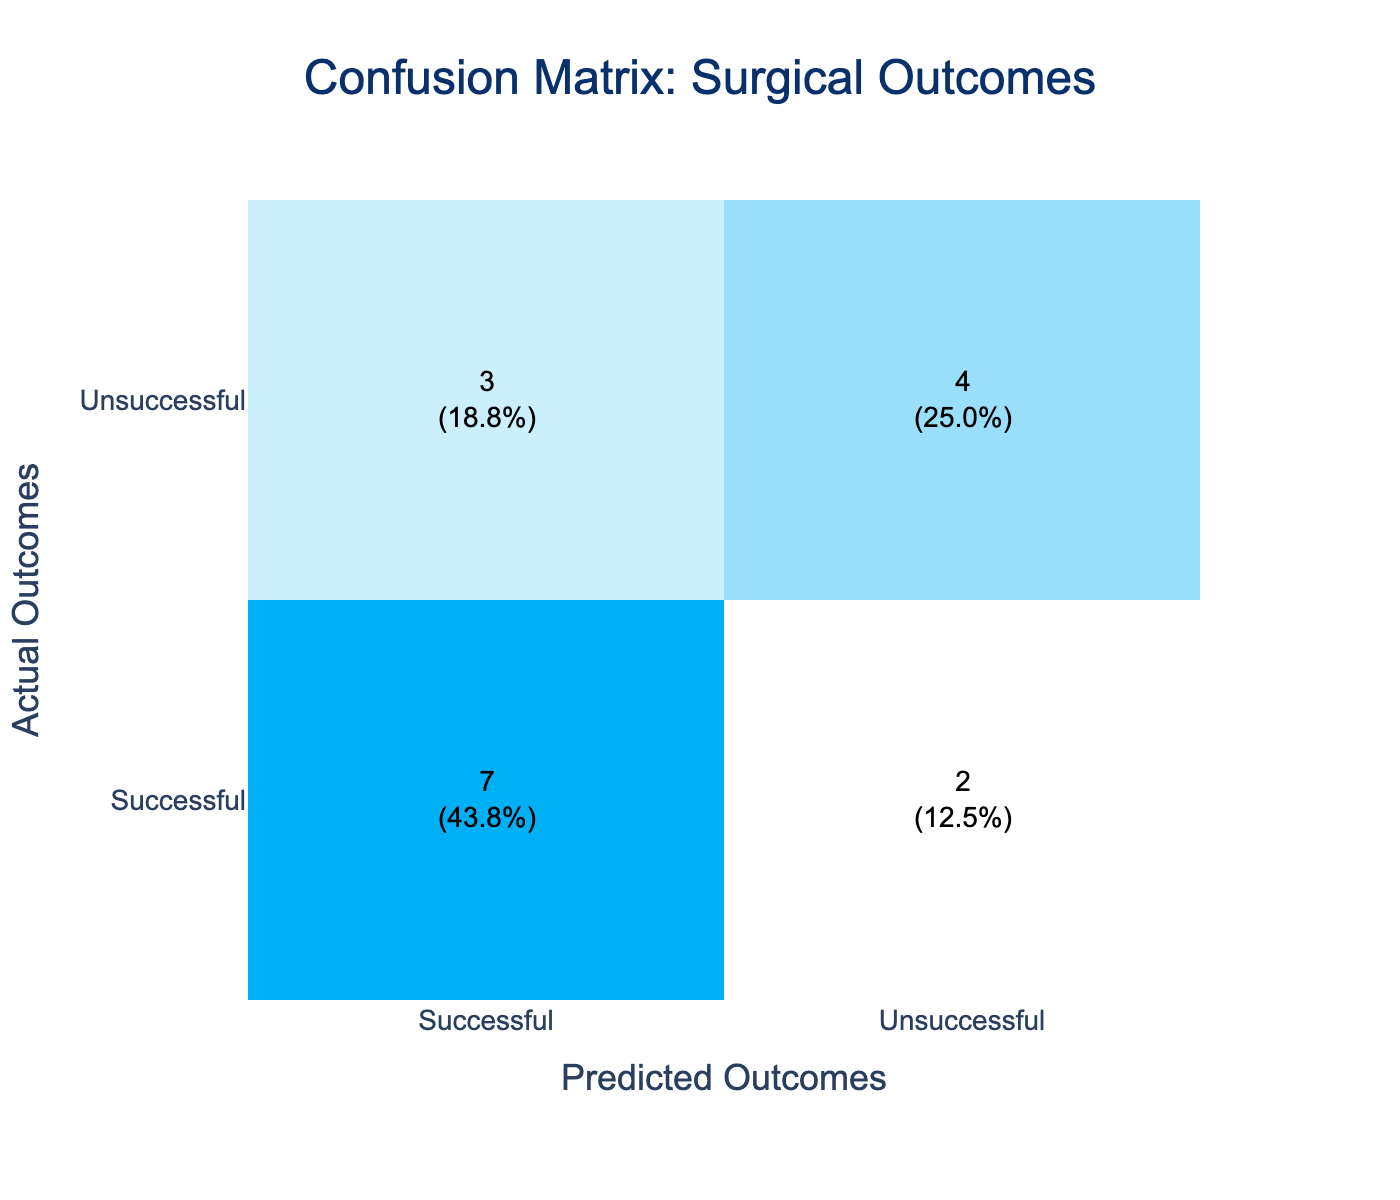What is the total number of surgeries represented in the table? To find the total number of surgeries, we can sum the counts in the confusion matrix. The confused categories are Successful and Unsuccessful. Counting from the table gives us 16.
Answer: 16 How many successful surgeries were predicted as unsuccessful? From the table, we can see that there are 3 instances where Successful surgeries were predicted as Unsuccessful.
Answer: 3 What percentage of unsuccessful surgeries were predicted correctly? The table shows that there are 5 Unsuccessful surgeries out of 10 total Unsuccessful predictions (5 actual Unsuccessful and 5 actual Successful). To find the percentage, we calculate (5/10)*100 = 50%.
Answer: 50% Is it true that the majority of surgeries were predicted correctly? The table indicates that there are 8 correctly predicted Successful surgeries and 5 correctly predicted Unsuccessful surgeries, totaling 13 correct predictions out of 16. Since 13 is more than half of 16, it is true.
Answer: Yes What is the difference between the number of successful surgeries and unsuccessful surgeries that were predicted correctly? The count of correct predictions for Successful surgeries is 8 and for Unsuccessful surgeries is 5. The difference is 8 - 5 = 3.
Answer: 3 What is the total number of unsuccessful surgeries predicted as successful? According to the confusion matrix, there are 4 Unsuccessful surgeries that were predicted as Successful.
Answer: 4 What is the accuracy of the predictions? The accuracy can be calculated as the ratio of correctly predicted surgeries to the total number of surgeries. Here, it is (8 + 5) / 16 = 13/16. Calculating gives us approximately 0.8125 or 81.25%.
Answer: 81.25% How many total successful surgeries were predicted? By counting from the table, we find there are 11 instances of Successful predicted outcomes (both correctly and incorrectly).
Answer: 11 What is the ratio of actual successful surgeries to actual unsuccessful surgeries based on the predictions? The confusion matrix shows there are 11 Successful surgeries and 5 Unsuccessful surgeries. Thus, the ratio is 11:5, which simplifies to 2.2:1.
Answer: 2.2:1 